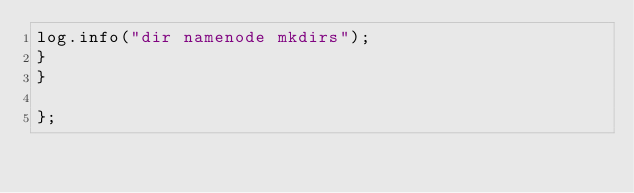<code> <loc_0><loc_0><loc_500><loc_500><_Java_>log.info("dir namenode mkdirs");
}
}

};</code> 